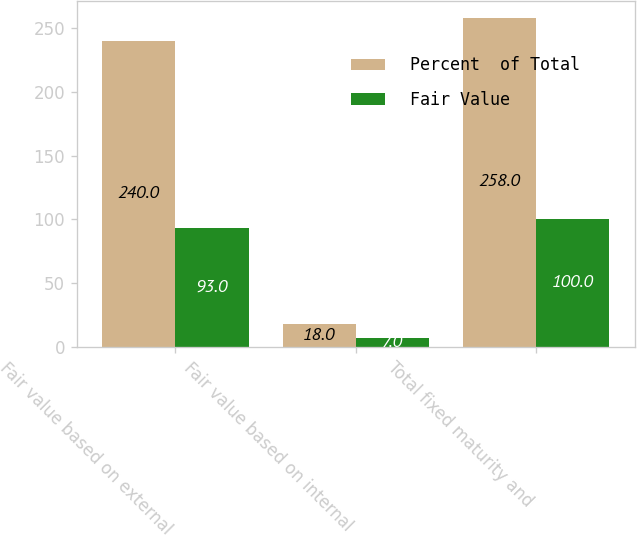Convert chart to OTSL. <chart><loc_0><loc_0><loc_500><loc_500><stacked_bar_chart><ecel><fcel>Fair value based on external<fcel>Fair value based on internal<fcel>Total fixed maturity and<nl><fcel>Percent  of Total<fcel>240<fcel>18<fcel>258<nl><fcel>Fair Value<fcel>93<fcel>7<fcel>100<nl></chart> 